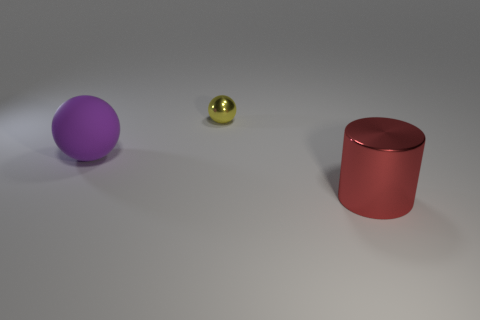Add 2 large red metallic things. How many objects exist? 5 Subtract all yellow spheres. How many spheres are left? 1 Subtract all balls. How many objects are left? 1 Subtract 0 green cylinders. How many objects are left? 3 Subtract 1 spheres. How many spheres are left? 1 Subtract all cyan balls. Subtract all gray cubes. How many balls are left? 2 Subtract all yellow cylinders. How many yellow balls are left? 1 Subtract all big yellow metal cylinders. Subtract all purple matte balls. How many objects are left? 2 Add 2 yellow metallic spheres. How many yellow metallic spheres are left? 3 Add 2 purple rubber spheres. How many purple rubber spheres exist? 3 